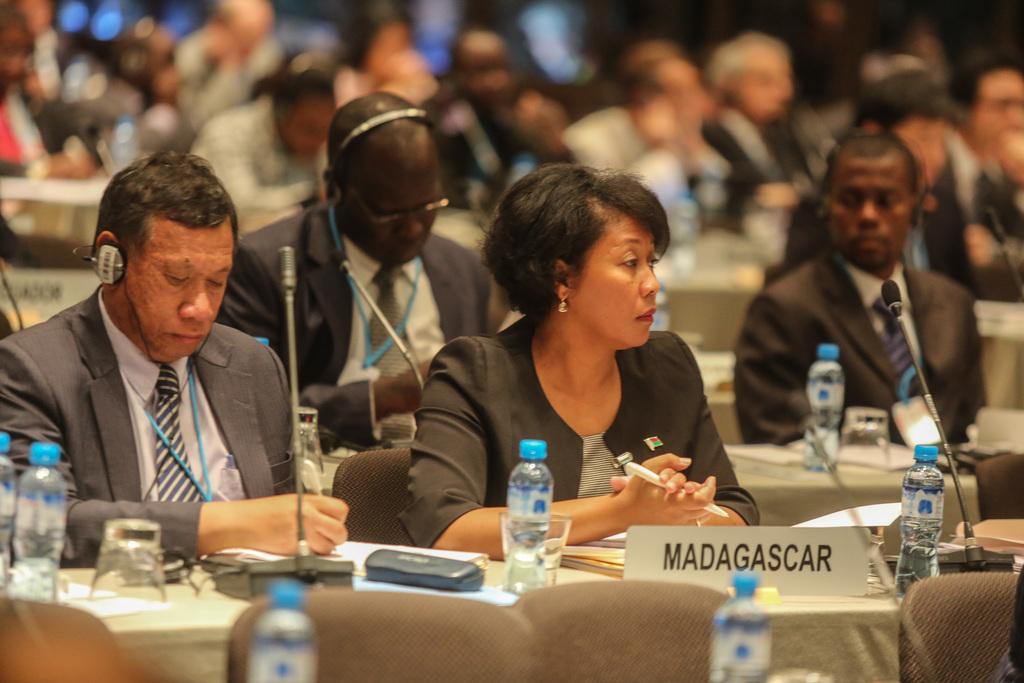Describe this image in one or two sentences. In the image there are many people sitting in front of the tables and on the tables there are mice, bottles, papers and other things. In the picture only three people were highlighted and the remaining people were blurred. 